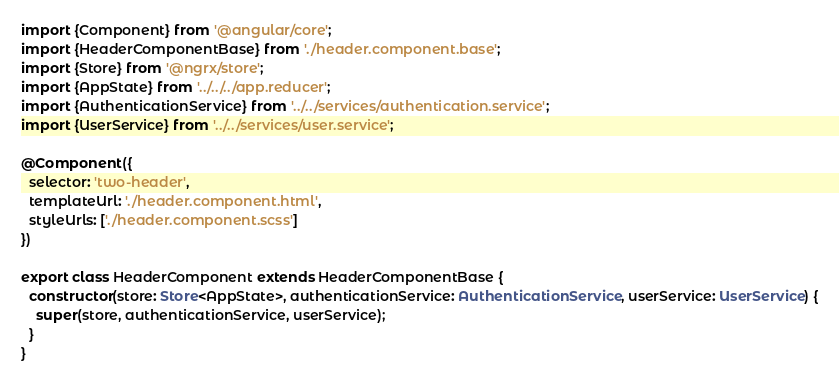<code> <loc_0><loc_0><loc_500><loc_500><_TypeScript_>import {Component} from '@angular/core';
import {HeaderComponentBase} from './header.component.base';
import {Store} from '@ngrx/store';
import {AppState} from '../../../app.reducer';
import {AuthenticationService} from '../../services/authentication.service';
import {UserService} from '../../services/user.service';

@Component({
  selector: 'two-header',
  templateUrl: './header.component.html',
  styleUrls: ['./header.component.scss']
})

export class HeaderComponent extends HeaderComponentBase {
  constructor(store: Store<AppState>, authenticationService: AuthenticationService, userService: UserService) {
    super(store, authenticationService, userService);
  }
}
</code> 